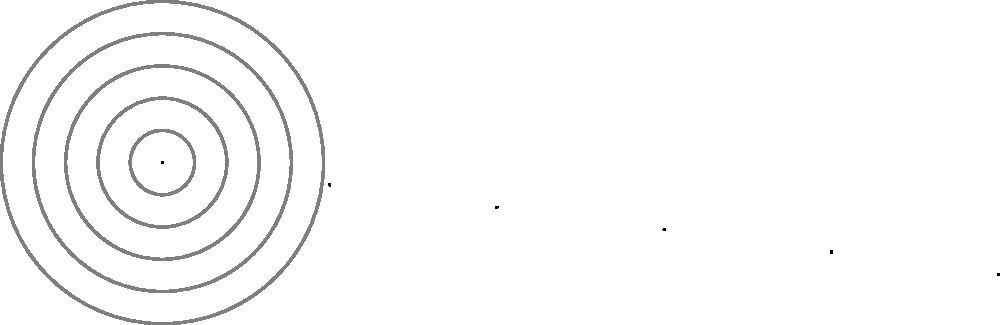As a project manager, you're allocating resources for a new software project. The polar chart represents the distribution of work hours across different areas. If the total project time is 500 hours, and the Backend sector covers 108 degrees, how many hours are allocated to Backend development? To solve this problem, we'll follow these steps:

1. Calculate the proportion of the full circle that the Backend sector represents:
   $\frac{108°}{360°} = 0.3$ or 30% of the circle

2. Since the total project time is 500 hours, and the Backend sector represents 30% of the total:
   $500 \text{ hours} \times 0.3 = 150 \text{ hours}$

The calculation can be generalized as:

$$\text{Backend Hours} = \text{Total Hours} \times \frac{\text{Backend Angle}}{360°}$$

$$\text{Backend Hours} = 500 \times \frac{108}{360} = 150$$

Therefore, 150 hours are allocated to Backend development.
Answer: 150 hours 